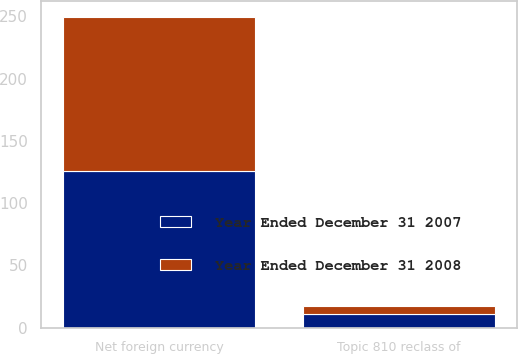Convert chart. <chart><loc_0><loc_0><loc_500><loc_500><stacked_bar_chart><ecel><fcel>Net foreign currency<fcel>Topic 810 reclass of<nl><fcel>Year Ended December 31 2007<fcel>126.1<fcel>10.8<nl><fcel>Year Ended December 31 2008<fcel>123.7<fcel>6.8<nl></chart> 